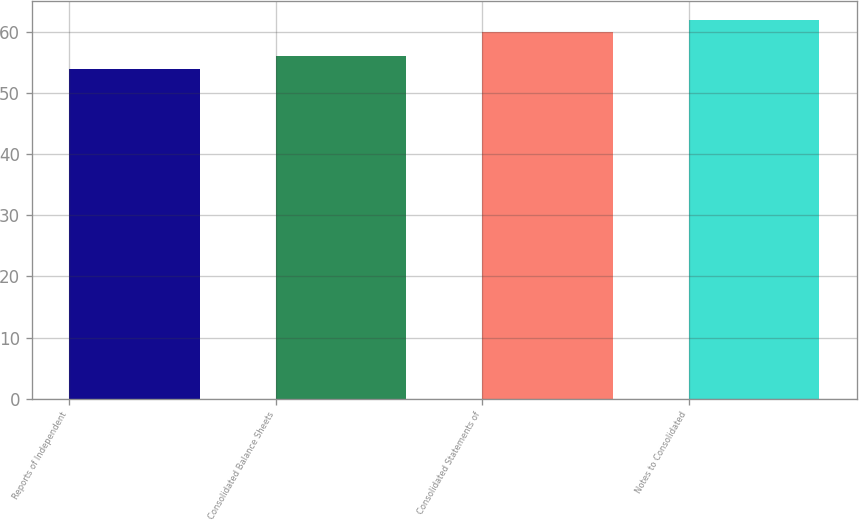Convert chart. <chart><loc_0><loc_0><loc_500><loc_500><bar_chart><fcel>Reports of Independent<fcel>Consolidated Balance Sheets<fcel>Consolidated Statements of<fcel>Notes to Consolidated<nl><fcel>54<fcel>56<fcel>60<fcel>62<nl></chart> 